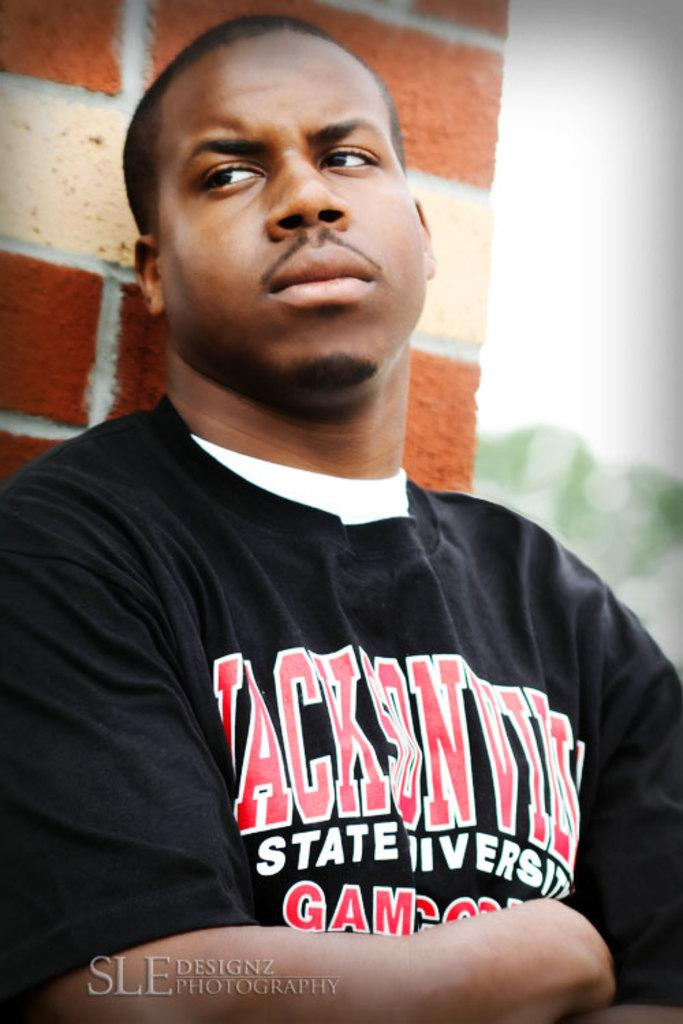<image>
Share a concise interpretation of the image provided. A guy wearing a jacksonville shirt stands against a wall looking mad. 